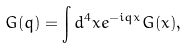Convert formula to latex. <formula><loc_0><loc_0><loc_500><loc_500>G ( q ) = \int d ^ { 4 } x e ^ { - i q x } G ( x ) ,</formula> 